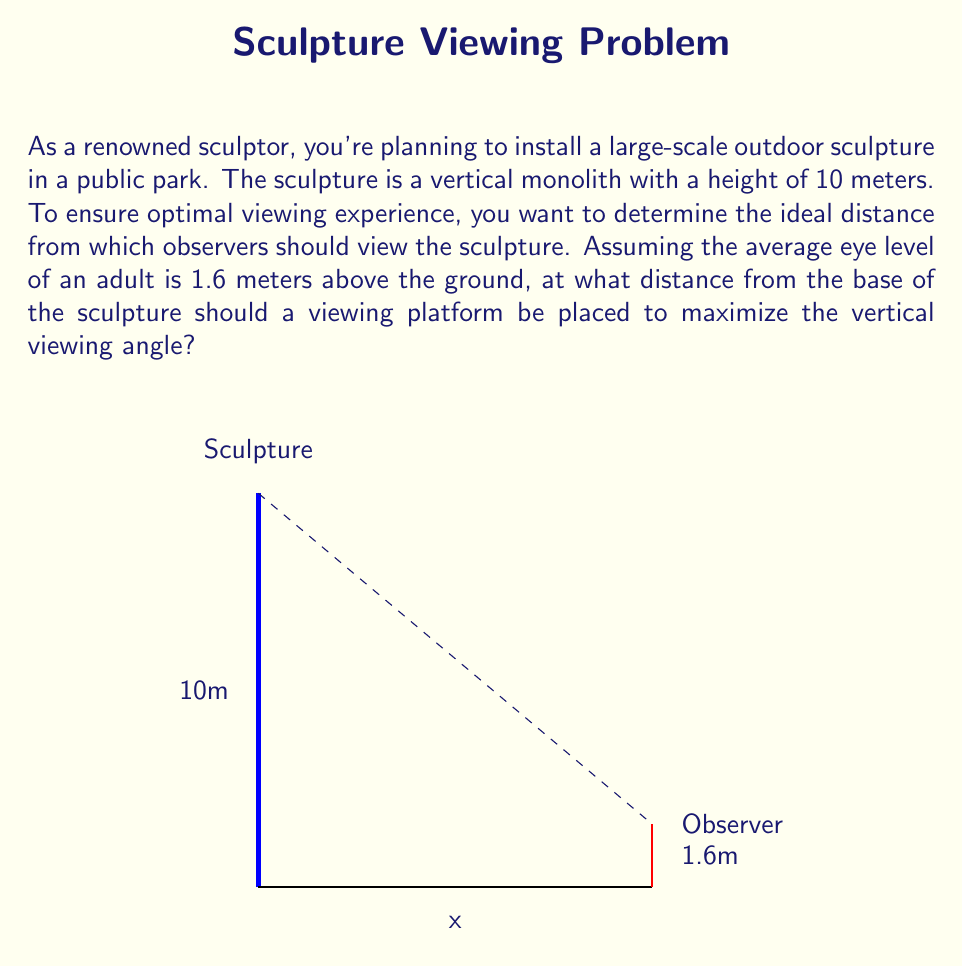Solve this math problem. Let's approach this step-by-step:

1) We need to maximize the vertical viewing angle. This angle is formed between the lines from the observer's eye to the top and bottom of the sculpture.

2) Let's define our variables:
   $h$ = height of sculpture = 10 meters
   $e$ = eye level height = 1.6 meters
   $x$ = distance from the base of the sculpture to the viewing platform

3) The tangent of the angle to the top of the sculpture is:
   $$\tan(\theta_1) = \frac{h}{x} = \frac{10}{x}$$

4) The tangent of the angle to the bottom of the sculpture is:
   $$\tan(\theta_2) = \frac{e}{x} = \frac{1.6}{x}$$

5) The total viewing angle $\theta$ is the difference between these:
   $$\theta = \theta_1 - \theta_2 = \arctan(\frac{10}{x}) - \arctan(\frac{1.6}{x})$$

6) To maximize this angle, we need to find where its derivative with respect to $x$ equals zero:
   $$\frac{d\theta}{dx} = \frac{-10}{x^2 + 100} + \frac{1.6}{x^2 + 2.56} = 0$$

7) Solving this equation:
   $$\frac{-10}{x^2 + 100} + \frac{1.6}{x^2 + 2.56} = 0$$
   $$\frac{-10(x^2 + 2.56) + 1.6(x^2 + 100)}{(x^2 + 100)(x^2 + 2.56)} = 0$$
   $$-8.4x^2 + 134.4 = 0$$
   $$x^2 = 16$$
   $$x = 4$$

8) The second derivative is negative at this point, confirming it's a maximum.

Therefore, the ideal viewing distance is 4 meters from the base of the sculpture.
Answer: 4 meters 